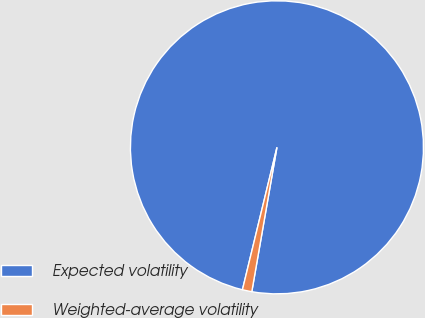<chart> <loc_0><loc_0><loc_500><loc_500><pie_chart><fcel>Expected volatility<fcel>Weighted-average volatility<nl><fcel>98.96%<fcel>1.04%<nl></chart> 